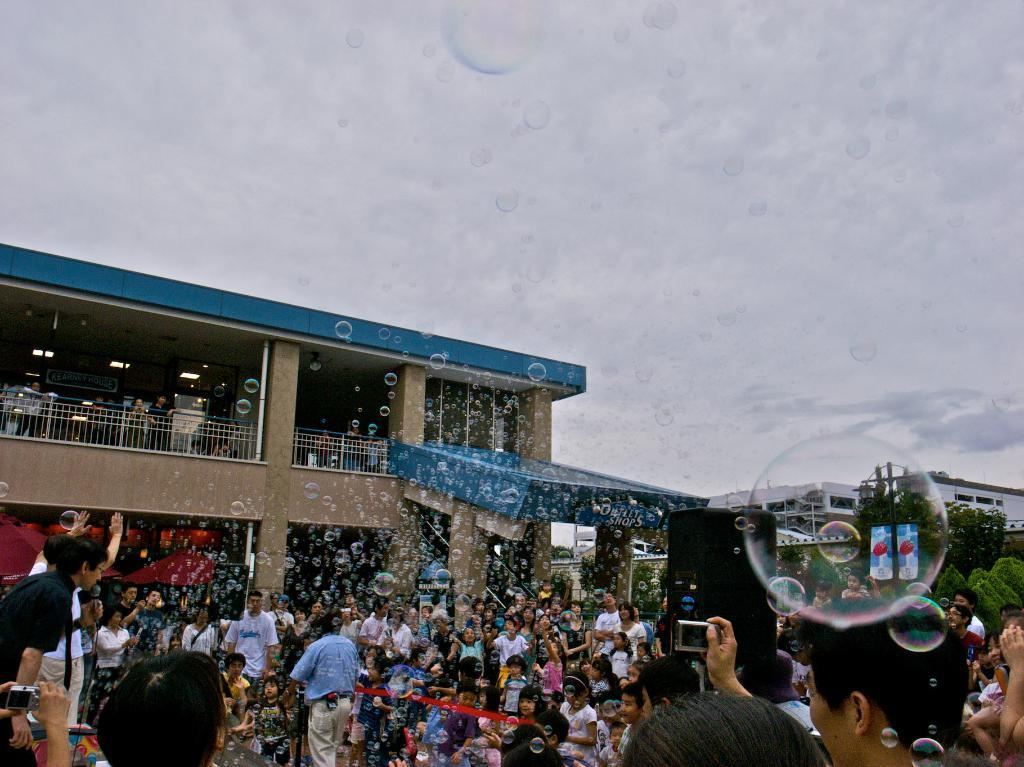What is located at the bottom of the picture? There are people, bubbles, trees, and buildings at the bottom of the picture. Can you describe the bubbles in the picture? There are bubbles at the bottom and in the middle of the picture. What is the condition of the sky in the image? The sky is cloudy in the image. What type of quartz can be seen in the picture? There is no quartz present in the image. Are there any people driving vehicles in the picture? There is no indication of any vehicles or driving in the image. 